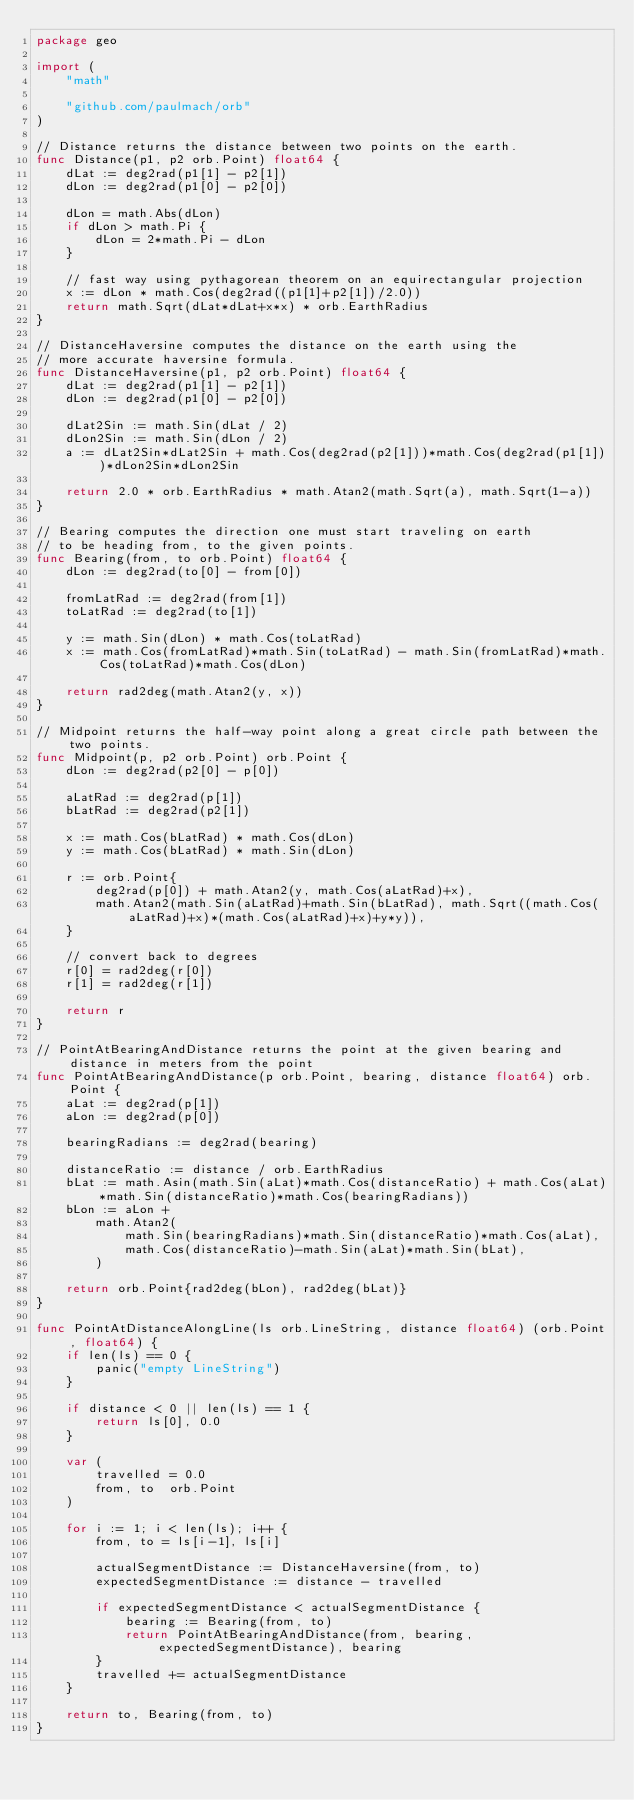<code> <loc_0><loc_0><loc_500><loc_500><_Go_>package geo

import (
	"math"

	"github.com/paulmach/orb"
)

// Distance returns the distance between two points on the earth.
func Distance(p1, p2 orb.Point) float64 {
	dLat := deg2rad(p1[1] - p2[1])
	dLon := deg2rad(p1[0] - p2[0])

	dLon = math.Abs(dLon)
	if dLon > math.Pi {
		dLon = 2*math.Pi - dLon
	}

	// fast way using pythagorean theorem on an equirectangular projection
	x := dLon * math.Cos(deg2rad((p1[1]+p2[1])/2.0))
	return math.Sqrt(dLat*dLat+x*x) * orb.EarthRadius
}

// DistanceHaversine computes the distance on the earth using the
// more accurate haversine formula.
func DistanceHaversine(p1, p2 orb.Point) float64 {
	dLat := deg2rad(p1[1] - p2[1])
	dLon := deg2rad(p1[0] - p2[0])

	dLat2Sin := math.Sin(dLat / 2)
	dLon2Sin := math.Sin(dLon / 2)
	a := dLat2Sin*dLat2Sin + math.Cos(deg2rad(p2[1]))*math.Cos(deg2rad(p1[1]))*dLon2Sin*dLon2Sin

	return 2.0 * orb.EarthRadius * math.Atan2(math.Sqrt(a), math.Sqrt(1-a))
}

// Bearing computes the direction one must start traveling on earth
// to be heading from, to the given points.
func Bearing(from, to orb.Point) float64 {
	dLon := deg2rad(to[0] - from[0])

	fromLatRad := deg2rad(from[1])
	toLatRad := deg2rad(to[1])

	y := math.Sin(dLon) * math.Cos(toLatRad)
	x := math.Cos(fromLatRad)*math.Sin(toLatRad) - math.Sin(fromLatRad)*math.Cos(toLatRad)*math.Cos(dLon)

	return rad2deg(math.Atan2(y, x))
}

// Midpoint returns the half-way point along a great circle path between the two points.
func Midpoint(p, p2 orb.Point) orb.Point {
	dLon := deg2rad(p2[0] - p[0])

	aLatRad := deg2rad(p[1])
	bLatRad := deg2rad(p2[1])

	x := math.Cos(bLatRad) * math.Cos(dLon)
	y := math.Cos(bLatRad) * math.Sin(dLon)

	r := orb.Point{
		deg2rad(p[0]) + math.Atan2(y, math.Cos(aLatRad)+x),
		math.Atan2(math.Sin(aLatRad)+math.Sin(bLatRad), math.Sqrt((math.Cos(aLatRad)+x)*(math.Cos(aLatRad)+x)+y*y)),
	}

	// convert back to degrees
	r[0] = rad2deg(r[0])
	r[1] = rad2deg(r[1])

	return r
}

// PointAtBearingAndDistance returns the point at the given bearing and distance in meters from the point
func PointAtBearingAndDistance(p orb.Point, bearing, distance float64) orb.Point {
	aLat := deg2rad(p[1])
	aLon := deg2rad(p[0])

	bearingRadians := deg2rad(bearing)

	distanceRatio := distance / orb.EarthRadius
	bLat := math.Asin(math.Sin(aLat)*math.Cos(distanceRatio) + math.Cos(aLat)*math.Sin(distanceRatio)*math.Cos(bearingRadians))
	bLon := aLon +
		math.Atan2(
			math.Sin(bearingRadians)*math.Sin(distanceRatio)*math.Cos(aLat),
			math.Cos(distanceRatio)-math.Sin(aLat)*math.Sin(bLat),
		)

	return orb.Point{rad2deg(bLon), rad2deg(bLat)}
}

func PointAtDistanceAlongLine(ls orb.LineString, distance float64) (orb.Point, float64) {
	if len(ls) == 0 {
		panic("empty LineString")
	}

	if distance < 0 || len(ls) == 1 {
		return ls[0], 0.0
	}

	var (
		travelled = 0.0
		from, to  orb.Point
	)

	for i := 1; i < len(ls); i++ {
		from, to = ls[i-1], ls[i]

		actualSegmentDistance := DistanceHaversine(from, to)
		expectedSegmentDistance := distance - travelled

		if expectedSegmentDistance < actualSegmentDistance {
			bearing := Bearing(from, to)
			return PointAtBearingAndDistance(from, bearing, expectedSegmentDistance), bearing
		}
		travelled += actualSegmentDistance
	}

	return to, Bearing(from, to)
}
</code> 